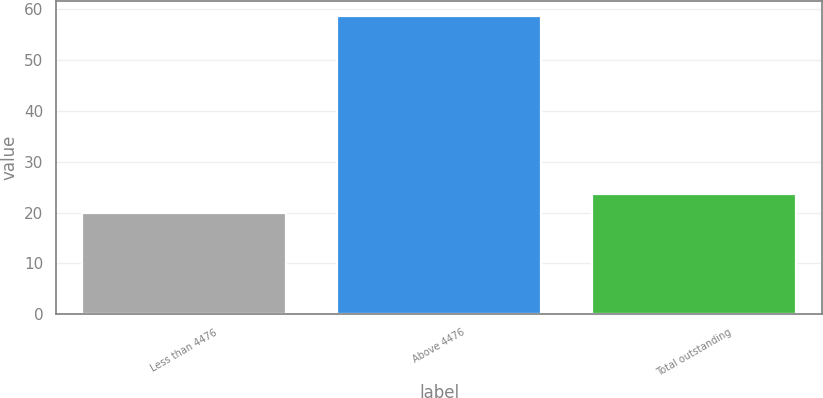Convert chart. <chart><loc_0><loc_0><loc_500><loc_500><bar_chart><fcel>Less than 4476<fcel>Above 4476<fcel>Total outstanding<nl><fcel>19.84<fcel>58.66<fcel>23.72<nl></chart> 